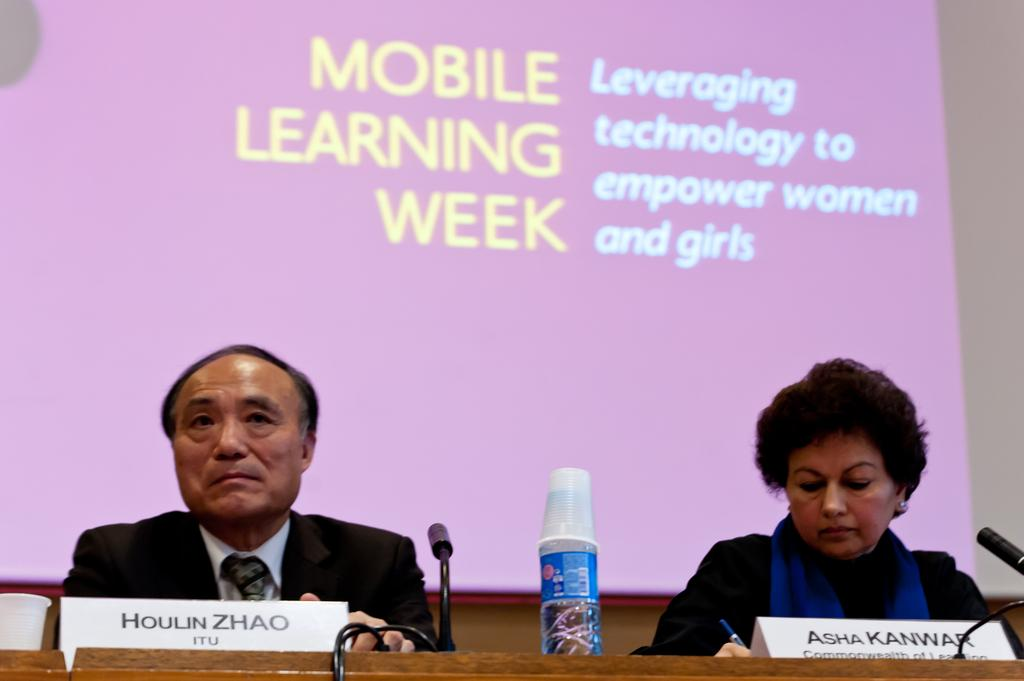<image>
Describe the image concisely. Houlin Zhao is seated at a table next to Asha Kanwar at Mobile Learning Week. 